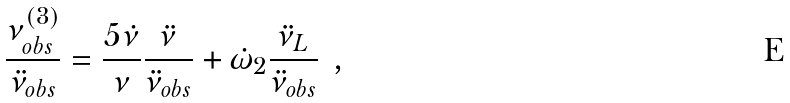<formula> <loc_0><loc_0><loc_500><loc_500>\frac { { \nu } ^ { ( 3 ) } _ { o b s } } { \ddot { \nu } _ { o b s } } = \frac { 5 \dot { \nu } } { \nu } \frac { \ddot { \nu } } { \ddot { \nu } _ { o b s } } + \dot { \omega } _ { 2 } \frac { \ddot { \nu } _ { L } } { \ddot { \nu } _ { o b s } } \ \, ,</formula> 